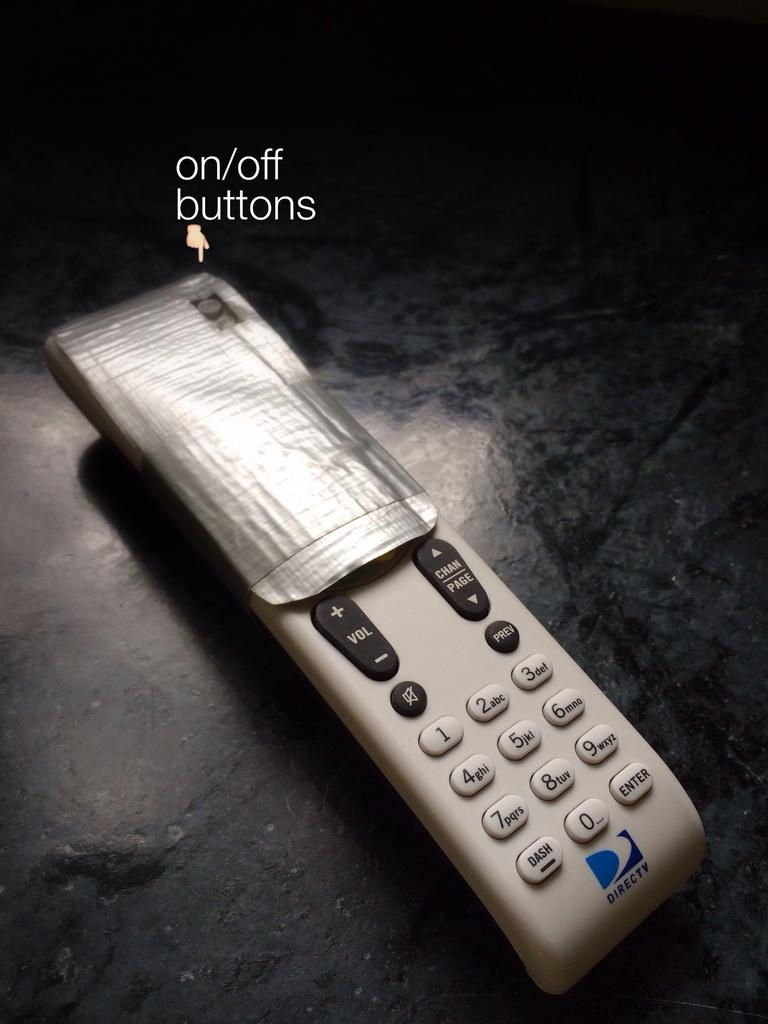Provide a one-sentence caption for the provided image. A DirecTV remote half covered with duct tape. 